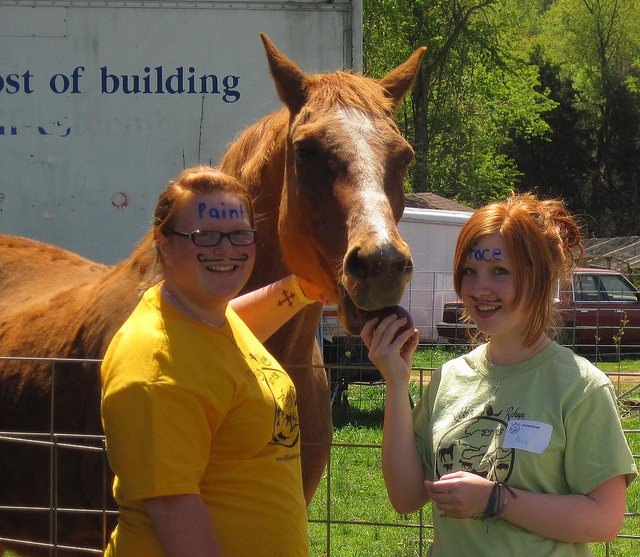Describe the objects in this image and their specific colors. I can see horse in gray, black, maroon, brown, and tan tones, people in gray, maroon, and black tones, people in gray, maroon, olive, and khaki tones, truck in gray and lightgray tones, and truck in gray, black, and maroon tones in this image. 